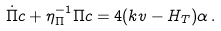Convert formula to latex. <formula><loc_0><loc_0><loc_500><loc_500>\dot { \Pi } c + \eta _ { \Pi } ^ { - 1 } \Pi c = 4 ( k v - H _ { T } ) \alpha \, .</formula> 